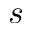<formula> <loc_0><loc_0><loc_500><loc_500>s</formula> 